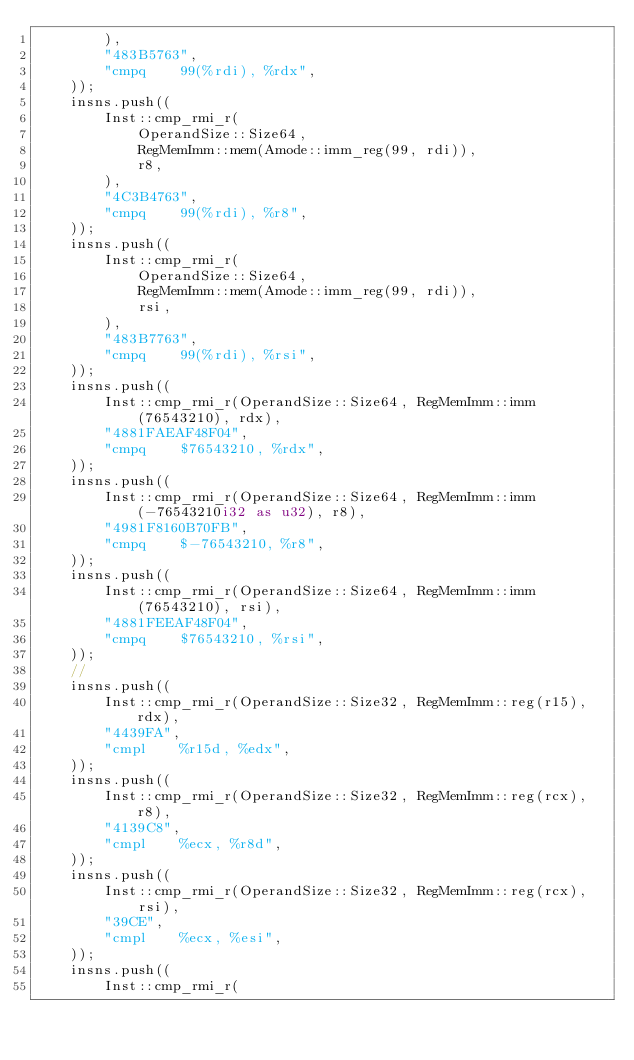Convert code to text. <code><loc_0><loc_0><loc_500><loc_500><_Rust_>        ),
        "483B5763",
        "cmpq    99(%rdi), %rdx",
    ));
    insns.push((
        Inst::cmp_rmi_r(
            OperandSize::Size64,
            RegMemImm::mem(Amode::imm_reg(99, rdi)),
            r8,
        ),
        "4C3B4763",
        "cmpq    99(%rdi), %r8",
    ));
    insns.push((
        Inst::cmp_rmi_r(
            OperandSize::Size64,
            RegMemImm::mem(Amode::imm_reg(99, rdi)),
            rsi,
        ),
        "483B7763",
        "cmpq    99(%rdi), %rsi",
    ));
    insns.push((
        Inst::cmp_rmi_r(OperandSize::Size64, RegMemImm::imm(76543210), rdx),
        "4881FAEAF48F04",
        "cmpq    $76543210, %rdx",
    ));
    insns.push((
        Inst::cmp_rmi_r(OperandSize::Size64, RegMemImm::imm(-76543210i32 as u32), r8),
        "4981F8160B70FB",
        "cmpq    $-76543210, %r8",
    ));
    insns.push((
        Inst::cmp_rmi_r(OperandSize::Size64, RegMemImm::imm(76543210), rsi),
        "4881FEEAF48F04",
        "cmpq    $76543210, %rsi",
    ));
    //
    insns.push((
        Inst::cmp_rmi_r(OperandSize::Size32, RegMemImm::reg(r15), rdx),
        "4439FA",
        "cmpl    %r15d, %edx",
    ));
    insns.push((
        Inst::cmp_rmi_r(OperandSize::Size32, RegMemImm::reg(rcx), r8),
        "4139C8",
        "cmpl    %ecx, %r8d",
    ));
    insns.push((
        Inst::cmp_rmi_r(OperandSize::Size32, RegMemImm::reg(rcx), rsi),
        "39CE",
        "cmpl    %ecx, %esi",
    ));
    insns.push((
        Inst::cmp_rmi_r(</code> 